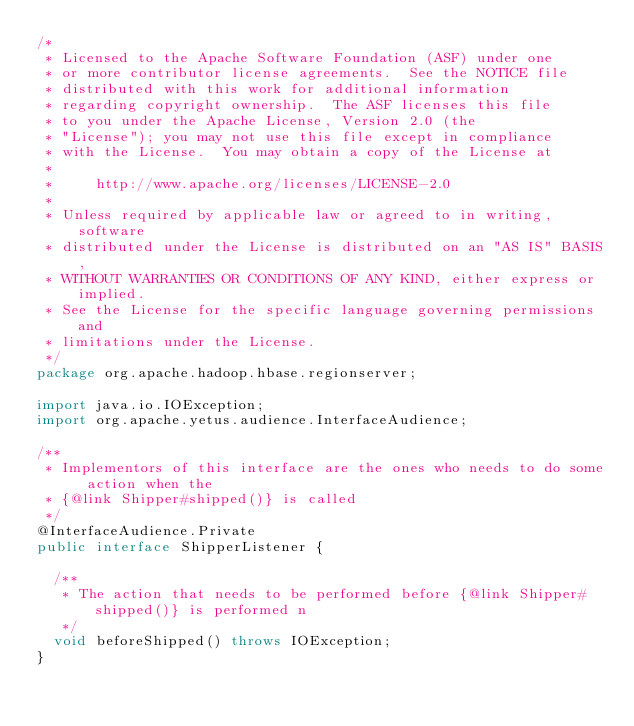<code> <loc_0><loc_0><loc_500><loc_500><_Java_>/*
 * Licensed to the Apache Software Foundation (ASF) under one
 * or more contributor license agreements.  See the NOTICE file
 * distributed with this work for additional information
 * regarding copyright ownership.  The ASF licenses this file
 * to you under the Apache License, Version 2.0 (the
 * "License"); you may not use this file except in compliance
 * with the License.  You may obtain a copy of the License at
 *
 *     http://www.apache.org/licenses/LICENSE-2.0
 *
 * Unless required by applicable law or agreed to in writing, software
 * distributed under the License is distributed on an "AS IS" BASIS,
 * WITHOUT WARRANTIES OR CONDITIONS OF ANY KIND, either express or implied.
 * See the License for the specific language governing permissions and
 * limitations under the License.
 */
package org.apache.hadoop.hbase.regionserver;

import java.io.IOException;
import org.apache.yetus.audience.InterfaceAudience;

/**
 * Implementors of this interface are the ones who needs to do some action when the
 * {@link Shipper#shipped()} is called
 */
@InterfaceAudience.Private
public interface ShipperListener {

  /**
   * The action that needs to be performed before {@link Shipper#shipped()} is performed n
   */
  void beforeShipped() throws IOException;
}
</code> 